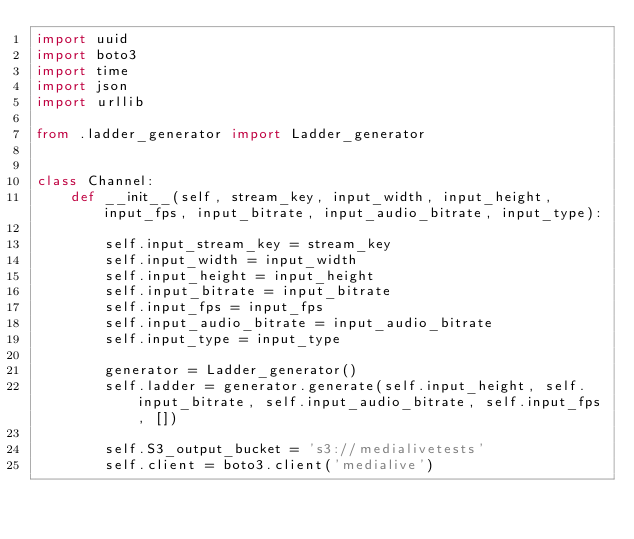<code> <loc_0><loc_0><loc_500><loc_500><_Python_>import uuid
import boto3
import time
import json
import urllib

from .ladder_generator import Ladder_generator


class Channel:
    def __init__(self, stream_key, input_width, input_height, input_fps, input_bitrate, input_audio_bitrate, input_type):

        self.input_stream_key = stream_key
        self.input_width = input_width
        self.input_height = input_height
        self.input_bitrate = input_bitrate
        self.input_fps = input_fps
        self.input_audio_bitrate = input_audio_bitrate
        self.input_type = input_type
        
        generator = Ladder_generator()
        self.ladder = generator.generate(self.input_height, self.input_bitrate, self.input_audio_bitrate, self.input_fps, [])
        
        self.S3_output_bucket = 's3://medialivetests'
        self.client = boto3.client('medialive')
        </code> 